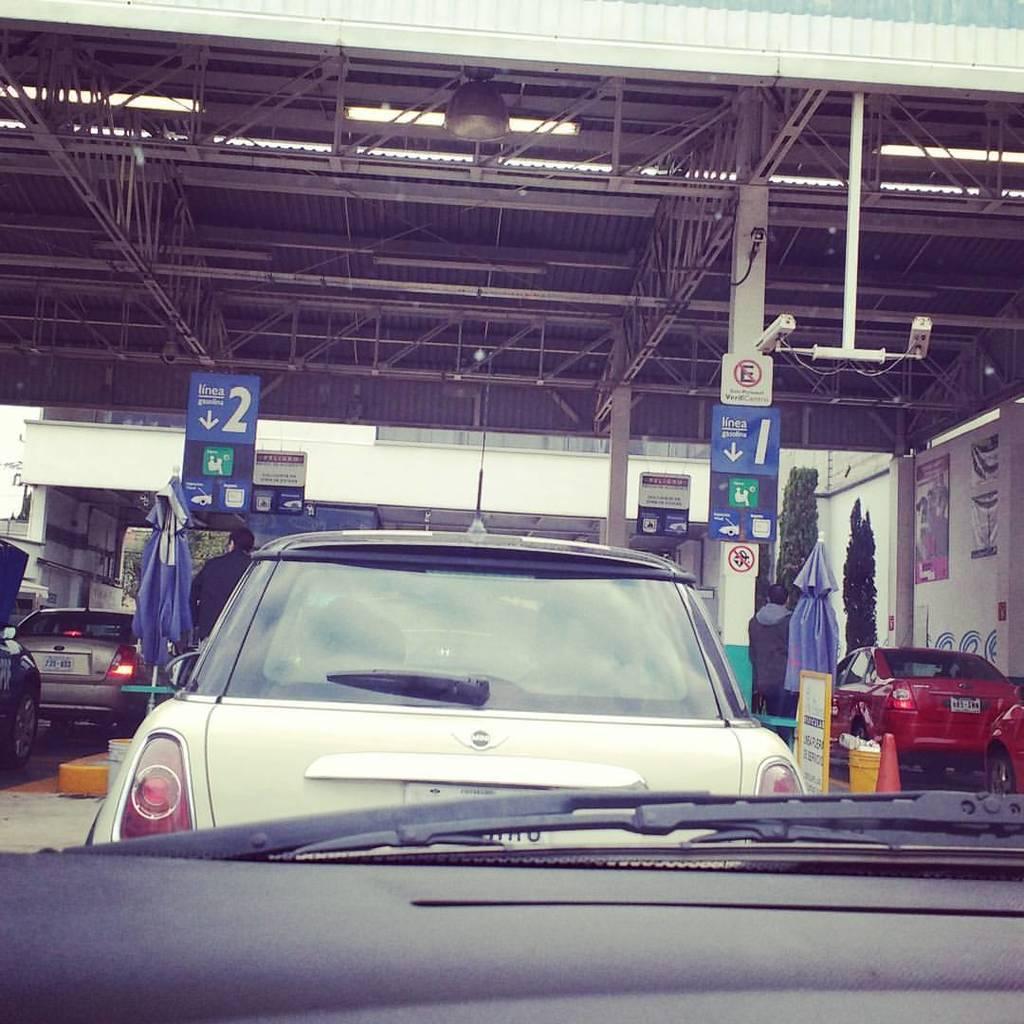Can you describe this image briefly? In this picture there are cars in the center of the image and there are other cars on the right and left side of the image, there are posters on the pillars and there is a roof at the top side of the image. 